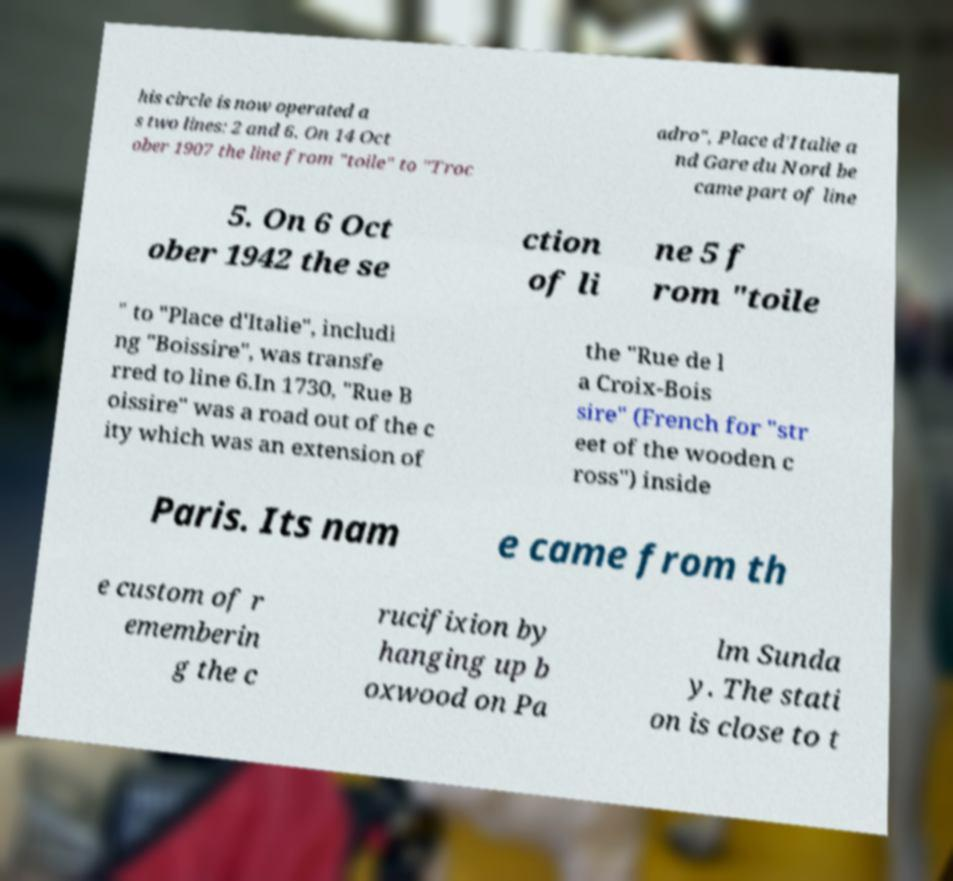Can you accurately transcribe the text from the provided image for me? his circle is now operated a s two lines: 2 and 6. On 14 Oct ober 1907 the line from "toile" to "Troc adro", Place d'Italie a nd Gare du Nord be came part of line 5. On 6 Oct ober 1942 the se ction of li ne 5 f rom "toile " to "Place d'Italie", includi ng "Boissire", was transfe rred to line 6.In 1730, "Rue B oissire" was a road out of the c ity which was an extension of the "Rue de l a Croix-Bois sire" (French for "str eet of the wooden c ross") inside Paris. Its nam e came from th e custom of r ememberin g the c rucifixion by hanging up b oxwood on Pa lm Sunda y. The stati on is close to t 